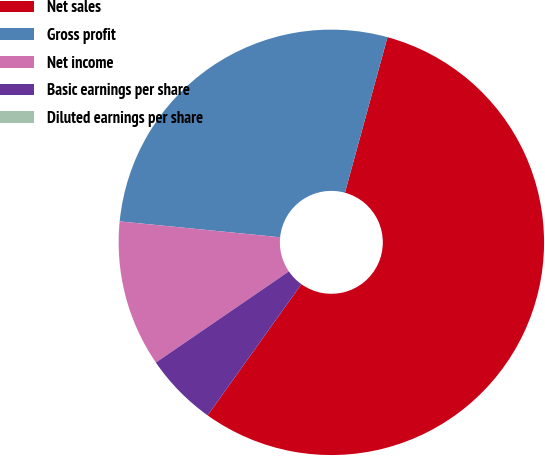Convert chart. <chart><loc_0><loc_0><loc_500><loc_500><pie_chart><fcel>Net sales<fcel>Gross profit<fcel>Net income<fcel>Basic earnings per share<fcel>Diluted earnings per share<nl><fcel>55.63%<fcel>27.68%<fcel>11.13%<fcel>5.56%<fcel>0.0%<nl></chart> 